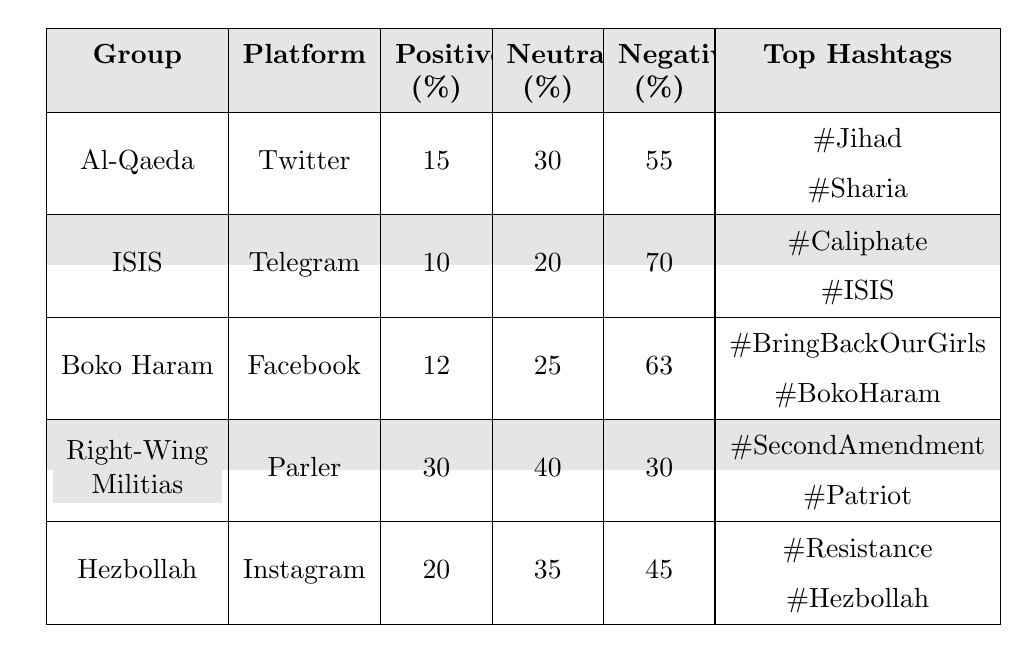What is the positive sentiment percentage for Hezbollah? The table lists the positive sentiment percentage for Hezbollah as 20%.
Answer: 20% Which extremist group has the highest neutral sentiment percentage? Looking at the neutral sentiment percentages, Right-Wing Militias have 40%, which is the highest among all groups.
Answer: Right-Wing Militias What is the total negative sentiment percentage for ISIS and Boko Haram combined? The negative sentiment percentage for ISIS is 70% and for Boko Haram is 63%. Adding them gives 70 + 63 = 133%.
Answer: 133% True or False: The positive sentiment percentage for Al-Qaeda is higher than that for Boko Haram. The positive sentiment percentage for Al-Qaeda is 15%, while for Boko Haram, it is 12%. Since 15% is greater than 12%, the statement is true.
Answer: True Which platform has the lowest positive sentiment percentage for any extremist group? The positive sentiment percentage for ISIS on Telegram is 10%, which is the lowest listed in the table.
Answer: Telegram What is the difference in negative sentiment percentages between Al-Qaeda and Right-Wing Militias? Al-Qaeda has a negative sentiment percentage of 55% and Right-Wing Militias have 30%. The difference is 55 - 30 = 25%.
Answer: 25% What are the common hashtags for Boko Haram? The table lists the most common hashtags for Boko Haram as #BringBackOurGirls and #BokoHaram.
Answer: #BringBackOurGirls and #BokoHaram Which extremist group has the highest percentage of negative sentiment, and what is that percentage? ISIS has the highest negative sentiment percentage at 70%.
Answer: ISIS, 70% What can be inferred about the sentiments towards Hezbollah compared to Al-Qaeda? Hezbollah has a positive percentage of 20% and negative of 45%, while Al-Qaeda has 15% positive and 55% negative. Hence, Hezbollah shows slightly more positive sentiment and less negative sentiment compared to Al-Qaeda.
Answer: Hezbollah shows more positive sentiment than Al-Qaeda If we average the positive sentiment percentages of all groups, what would be the result? The sum of positive sentiments is 15 + 10 + 12 + 30 + 20 = 87%, and there are 5 groups. Therefore, the average is 87 / 5 = 17.4%.
Answer: 17.4% 